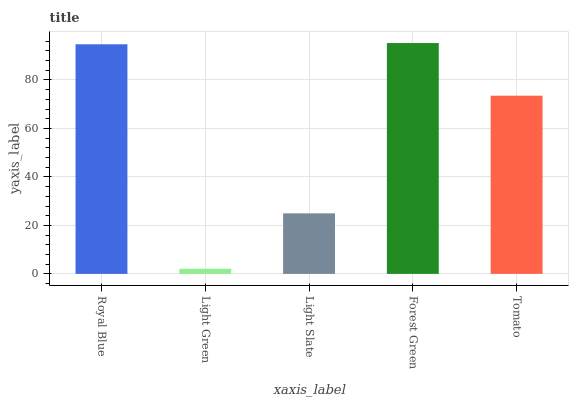Is Light Green the minimum?
Answer yes or no. Yes. Is Forest Green the maximum?
Answer yes or no. Yes. Is Light Slate the minimum?
Answer yes or no. No. Is Light Slate the maximum?
Answer yes or no. No. Is Light Slate greater than Light Green?
Answer yes or no. Yes. Is Light Green less than Light Slate?
Answer yes or no. Yes. Is Light Green greater than Light Slate?
Answer yes or no. No. Is Light Slate less than Light Green?
Answer yes or no. No. Is Tomato the high median?
Answer yes or no. Yes. Is Tomato the low median?
Answer yes or no. Yes. Is Forest Green the high median?
Answer yes or no. No. Is Royal Blue the low median?
Answer yes or no. No. 